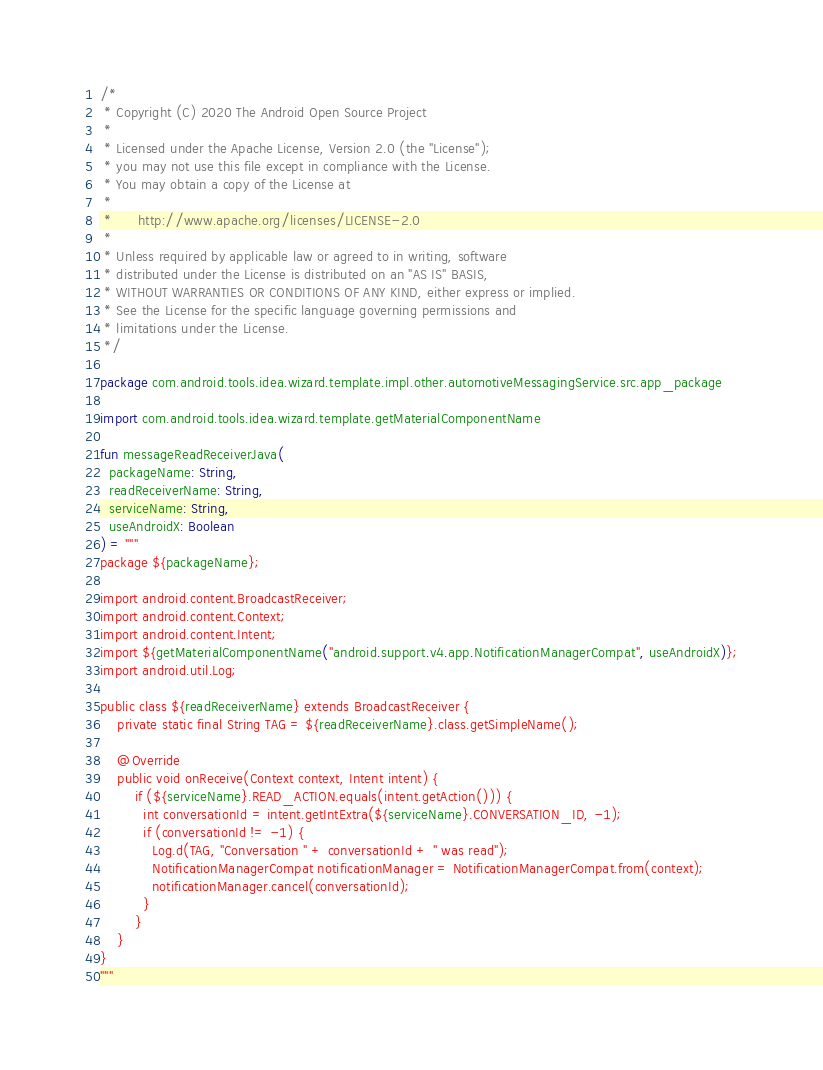Convert code to text. <code><loc_0><loc_0><loc_500><loc_500><_Kotlin_>/*
 * Copyright (C) 2020 The Android Open Source Project
 *
 * Licensed under the Apache License, Version 2.0 (the "License");
 * you may not use this file except in compliance with the License.
 * You may obtain a copy of the License at
 *
 *      http://www.apache.org/licenses/LICENSE-2.0
 *
 * Unless required by applicable law or agreed to in writing, software
 * distributed under the License is distributed on an "AS IS" BASIS,
 * WITHOUT WARRANTIES OR CONDITIONS OF ANY KIND, either express or implied.
 * See the License for the specific language governing permissions and
 * limitations under the License.
 */

package com.android.tools.idea.wizard.template.impl.other.automotiveMessagingService.src.app_package

import com.android.tools.idea.wizard.template.getMaterialComponentName

fun messageReadReceiverJava(
  packageName: String,
  readReceiverName: String,
  serviceName: String,
  useAndroidX: Boolean
) = """
package ${packageName};

import android.content.BroadcastReceiver;
import android.content.Context;
import android.content.Intent;
import ${getMaterialComponentName("android.support.v4.app.NotificationManagerCompat", useAndroidX)};
import android.util.Log;

public class ${readReceiverName} extends BroadcastReceiver {
    private static final String TAG = ${readReceiverName}.class.getSimpleName();

    @Override
    public void onReceive(Context context, Intent intent) {
        if (${serviceName}.READ_ACTION.equals(intent.getAction())) {
          int conversationId = intent.getIntExtra(${serviceName}.CONVERSATION_ID, -1);
          if (conversationId != -1) {
            Log.d(TAG, "Conversation " + conversationId + " was read");
            NotificationManagerCompat notificationManager = NotificationManagerCompat.from(context);
            notificationManager.cancel(conversationId);
          }
        }
    }
}
"""
</code> 